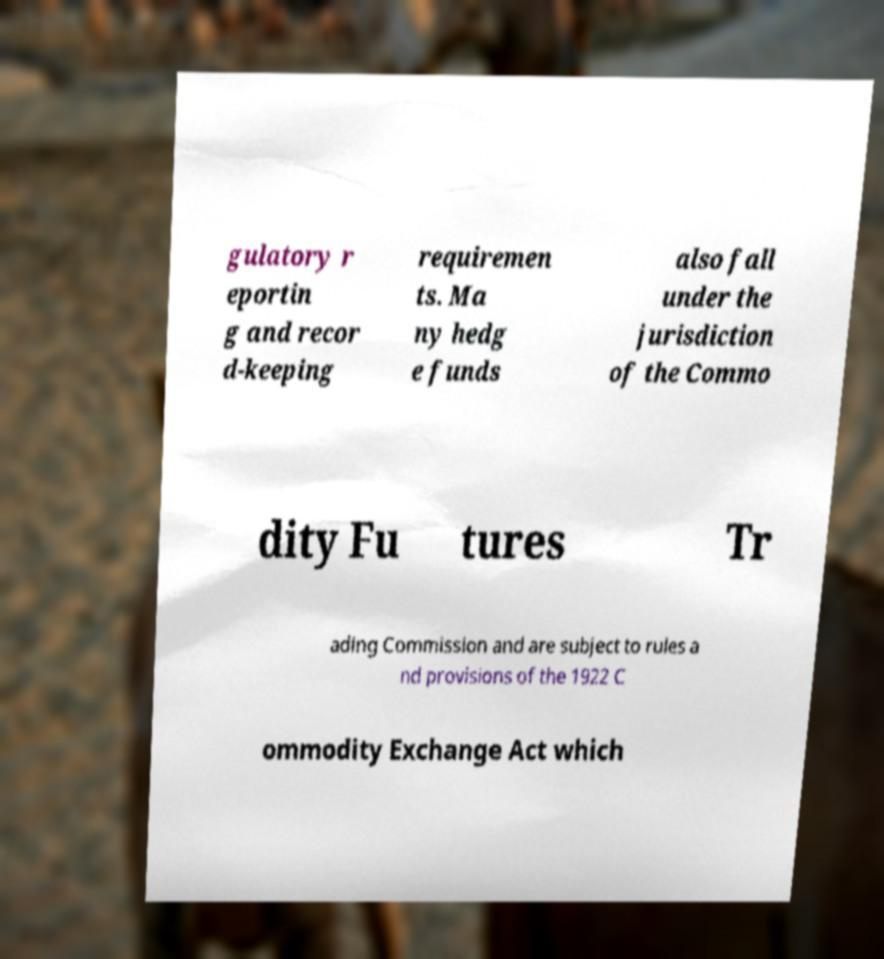For documentation purposes, I need the text within this image transcribed. Could you provide that? gulatory r eportin g and recor d-keeping requiremen ts. Ma ny hedg e funds also fall under the jurisdiction of the Commo dity Fu tures Tr ading Commission and are subject to rules a nd provisions of the 1922 C ommodity Exchange Act which 